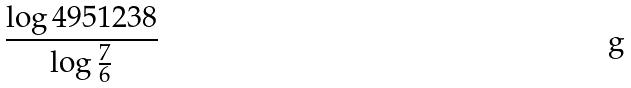Convert formula to latex. <formula><loc_0><loc_0><loc_500><loc_500>\frac { \log 4 9 5 1 2 3 8 } { \log \frac { 7 } { 6 } }</formula> 